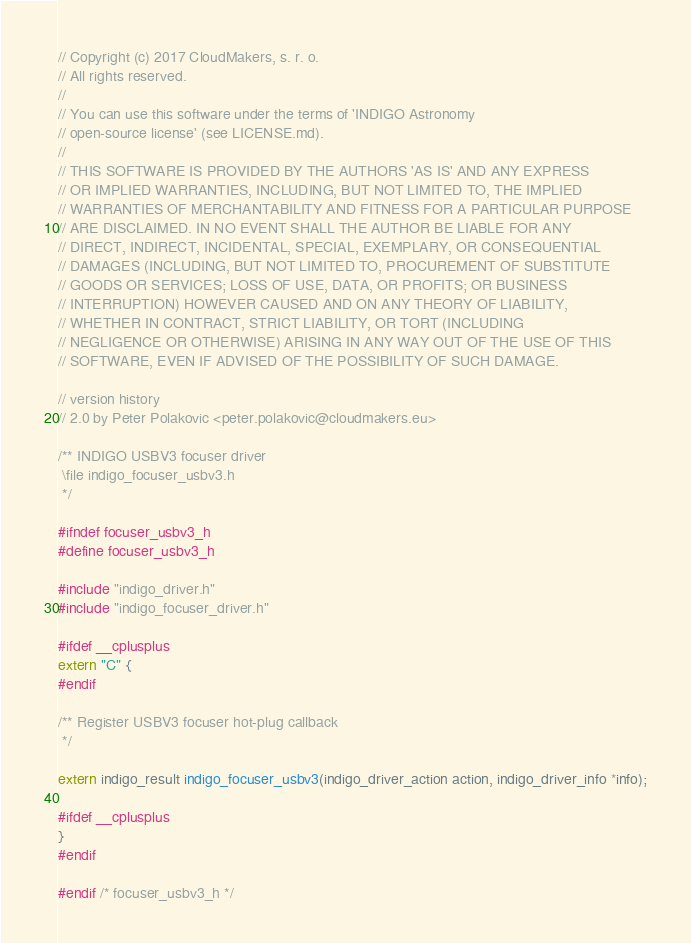<code> <loc_0><loc_0><loc_500><loc_500><_C_>// Copyright (c) 2017 CloudMakers, s. r. o.
// All rights reserved.
//
// You can use this software under the terms of 'INDIGO Astronomy
// open-source license' (see LICENSE.md).
//
// THIS SOFTWARE IS PROVIDED BY THE AUTHORS 'AS IS' AND ANY EXPRESS
// OR IMPLIED WARRANTIES, INCLUDING, BUT NOT LIMITED TO, THE IMPLIED
// WARRANTIES OF MERCHANTABILITY AND FITNESS FOR A PARTICULAR PURPOSE
// ARE DISCLAIMED. IN NO EVENT SHALL THE AUTHOR BE LIABLE FOR ANY
// DIRECT, INDIRECT, INCIDENTAL, SPECIAL, EXEMPLARY, OR CONSEQUENTIAL
// DAMAGES (INCLUDING, BUT NOT LIMITED TO, PROCUREMENT OF SUBSTITUTE
// GOODS OR SERVICES; LOSS OF USE, DATA, OR PROFITS; OR BUSINESS
// INTERRUPTION) HOWEVER CAUSED AND ON ANY THEORY OF LIABILITY,
// WHETHER IN CONTRACT, STRICT LIABILITY, OR TORT (INCLUDING
// NEGLIGENCE OR OTHERWISE) ARISING IN ANY WAY OUT OF THE USE OF THIS
// SOFTWARE, EVEN IF ADVISED OF THE POSSIBILITY OF SUCH DAMAGE.

// version history
// 2.0 by Peter Polakovic <peter.polakovic@cloudmakers.eu>

/** INDIGO USBV3 focuser driver
 \file indigo_focuser_usbv3.h
 */

#ifndef focuser_usbv3_h
#define focuser_usbv3_h

#include "indigo_driver.h"
#include "indigo_focuser_driver.h"

#ifdef __cplusplus
extern "C" {
#endif

/** Register USBV3 focuser hot-plug callback
 */

extern indigo_result indigo_focuser_usbv3(indigo_driver_action action, indigo_driver_info *info);

#ifdef __cplusplus
}
#endif

#endif /* focuser_usbv3_h */

</code> 